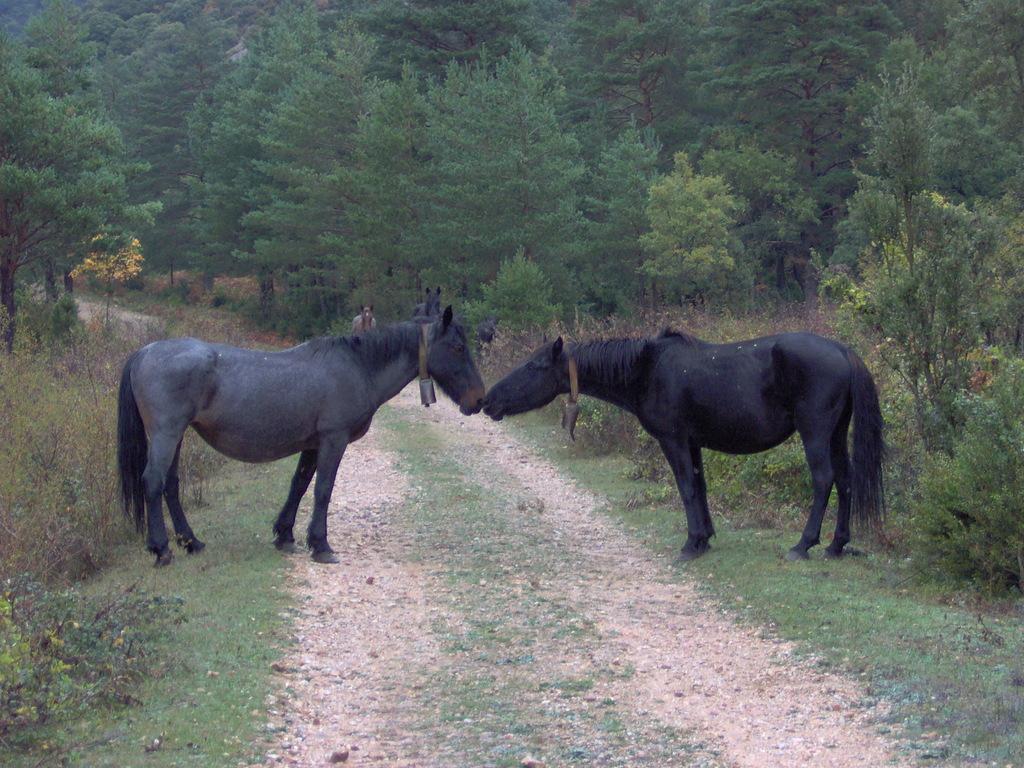Could you give a brief overview of what you see in this image? In this image we can see a road. On the ground there is grass. Also there are horses. Also there are trees and plants. In the back there is a person. 